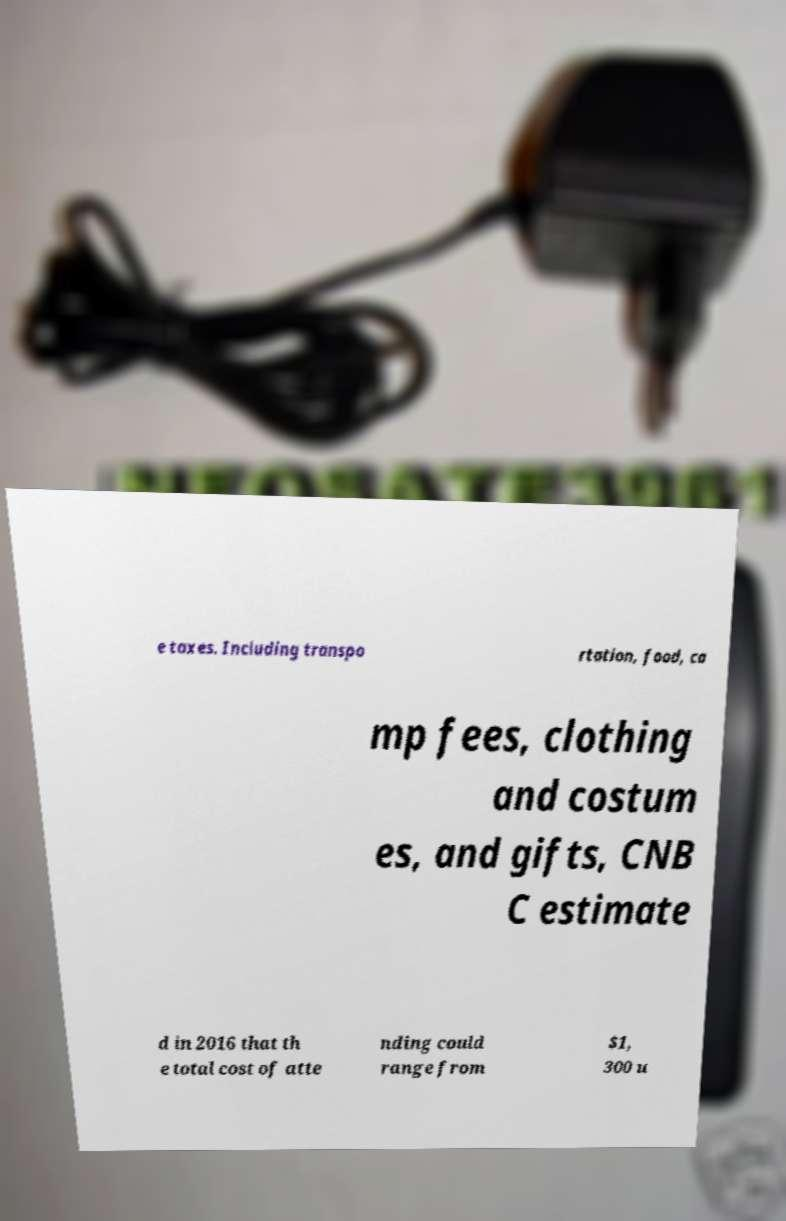Can you accurately transcribe the text from the provided image for me? e taxes. Including transpo rtation, food, ca mp fees, clothing and costum es, and gifts, CNB C estimate d in 2016 that th e total cost of atte nding could range from $1, 300 u 